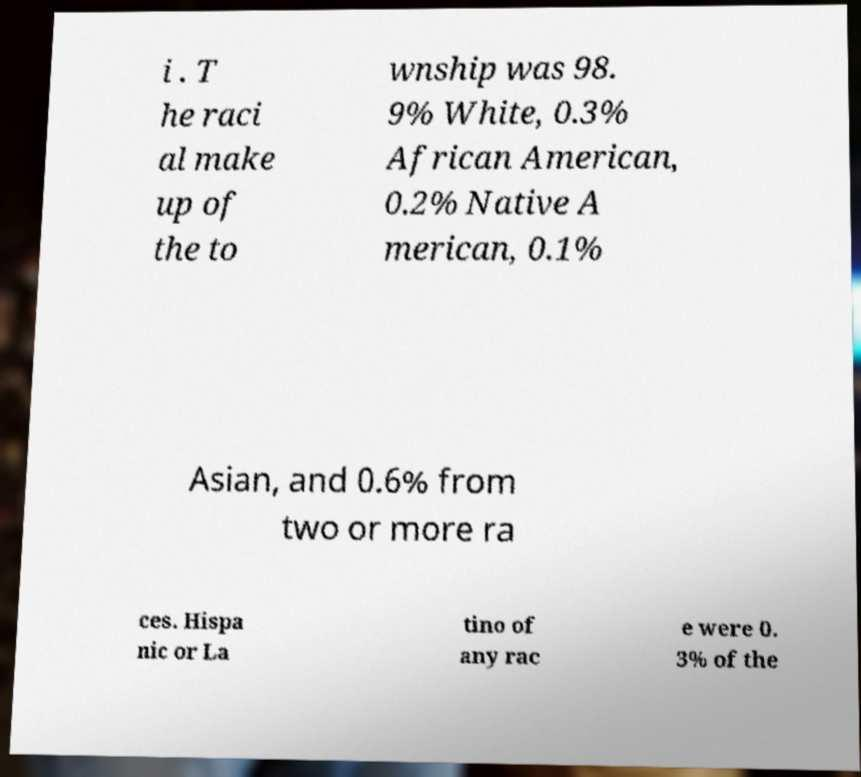Can you accurately transcribe the text from the provided image for me? i . T he raci al make up of the to wnship was 98. 9% White, 0.3% African American, 0.2% Native A merican, 0.1% Asian, and 0.6% from two or more ra ces. Hispa nic or La tino of any rac e were 0. 3% of the 